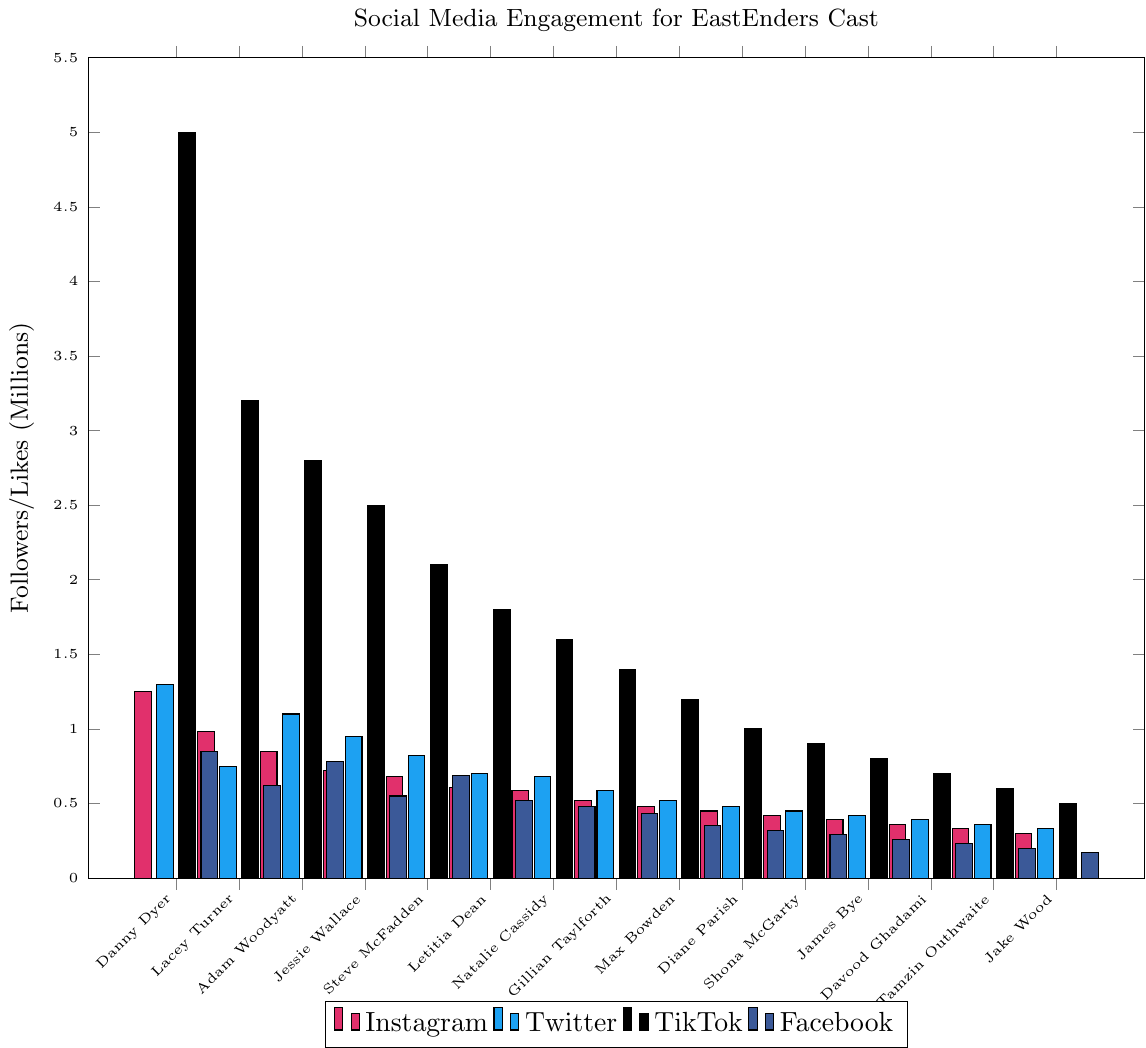Which character has the most Instagram followers? The bar chart indicates that the character Danny Dyer has the tallest bar in the Instagram category, implying he has the most Instagram followers.
Answer: Danny Dyer Which platform does Lacey Turner have the second highest engagement on? By observing Lacey Turner's bars, Instagram followers are 0.98M, Twitter followers are 0.75M, TikTok likes are 3.20M, and Facebook likes are 0.62M. TikTok likes being the highest, her second highest engagement is on Instagram.
Answer: Instagram Do any characters have equal followers on any two platforms? By checking the heights of the bars, no character has equal number of followers or likes on more than one platform.
Answer: No Who has more TikTok likes, Adam Woodyatt or Jessie Wallace? By comparing the heights of their TikTok bars, Adam Woodyatt has a bar of 2.8M while Jessie Wallace has a bar of 2.5M.
Answer: Adam Woodyatt Which character has the fewest Facebook page likes? The bar chart shows that Jake Wood has the shortest bar for Facebook page likes.
Answer: Jake Wood What is the combined number of Instagram and Twitter followers for Steve McFadden? Steve McFadden's Instagram followers are 0.68M and Twitter followers are 0.82M. Combining these, 0.68 + 0.82 equals 1.50M.
Answer: 1.50M How does Danny Dyer compare to Lacey Turner in terms of TikTok likes? Danny Dyer has 5.00M TikTok likes, while Lacey Turner has 3.20M TikTok likes. Danny Dyer has more TikTok likes than Lacey Turner.
Answer: Danny Dyer has more Which character has more total followers on Facebook and Instagram combined: Letitia Dean or Natalie Cassidy? Letitia Dean has 0.52M Facebook and 0.61M Instagram followers totaling 1.13M. Natalie Cassidy has 0.48M Facebook and 0.59M Instagram followers totaling 1.07M.
Answer: Letitia Dean Among these characters, who has the highest total engagement (followers/likes) across all platforms? By summing up the followers/likes for each character, Danny Dyer has 1.25M (Insta) + 1.30M (Twitter) + 5.00M (TikTok) + 0.85M (FB) totaling 8.40M, which is the highest among the characters.
Answer: Danny Dyer 